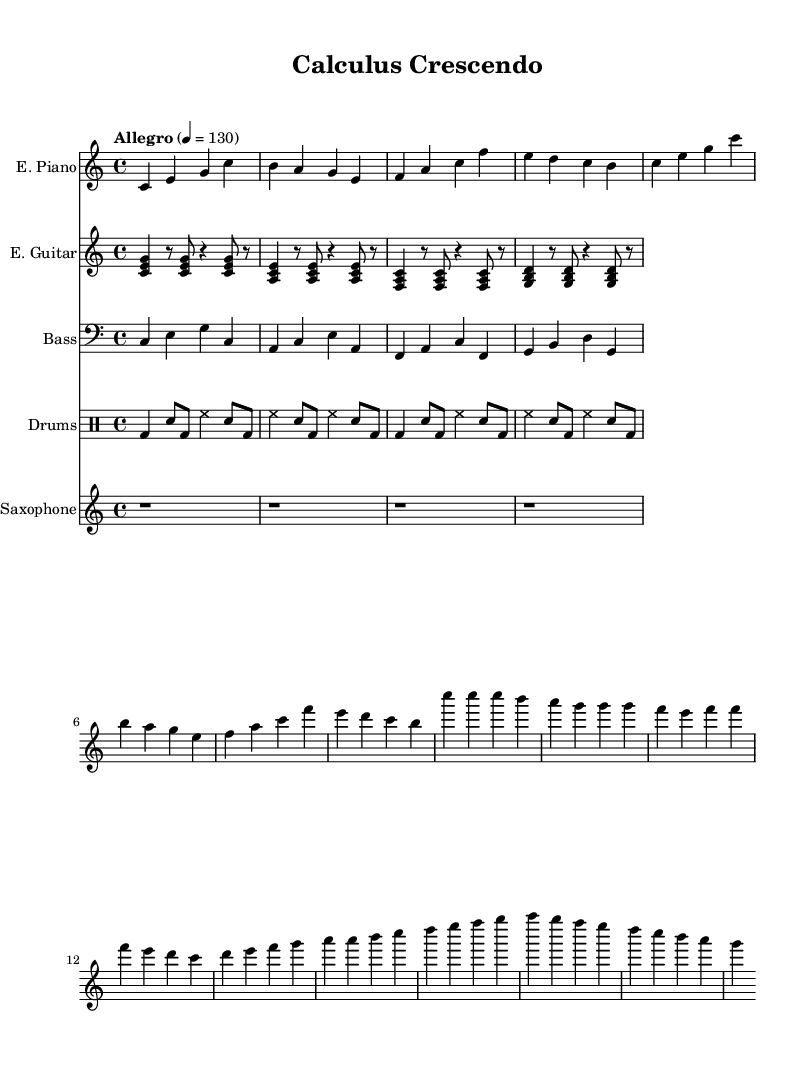What is the key signature of this music? The key signature is indicated at the beginning of the piece, showing no sharps or flats, which corresponds to C major.
Answer: C major What is the time signature of this music? The time signature is located at the start of the sheet music, and it shows a 4 over 4, meaning there are four beats in every measure and a quarter note gets one beat.
Answer: 4/4 What is the tempo marking for this piece? The tempo marking indicates how fast the music should be played, and in this case, it is marked as "Allegro" with a metronome marking of 130 beats per minute.
Answer: Allegro, 130 What instruments are featured in this piece? The sheet music lists five instrument parts: Electric Piano, Electric Guitar, Bass, Drums, and Saxophone, indicating a fusion setup typical of jazz-rock ensembles.
Answer: Electric Piano, Electric Guitar, Bass, Drums, Saxophone Describe the rhythmic style of the drums part. The drums part utilizes a basic jazz-rock beat characterized by a combination of bass drum (bd), snare (sn), and hi-hat (hh), creating a steady groove which is essential in jazz-rock music.
Answer: Jazz-rock beat How does the electric guitar part contribute to the piece? The electric guitar part uses comping rhythms with chords that outline the harmony, helping to create a harmonic foundation and adding color to the overall sound typical of fusion music.
Answer: Comping rhythm Identify a feature of the saxophone part in this piece. The saxophone part consists solely of rests in this section, which may suggest that it is reserved for a future solo, highlighting a common practice in jazz where instruments take turns in improvisation.
Answer: Solo placeholder 